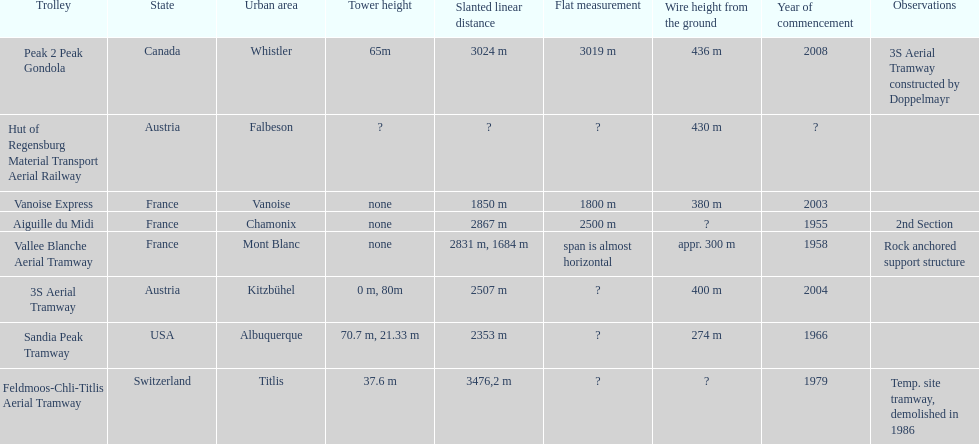Which tramway was inaugurated first, the 3s aerial tramway or the aiguille du midi? Aiguille du Midi. 